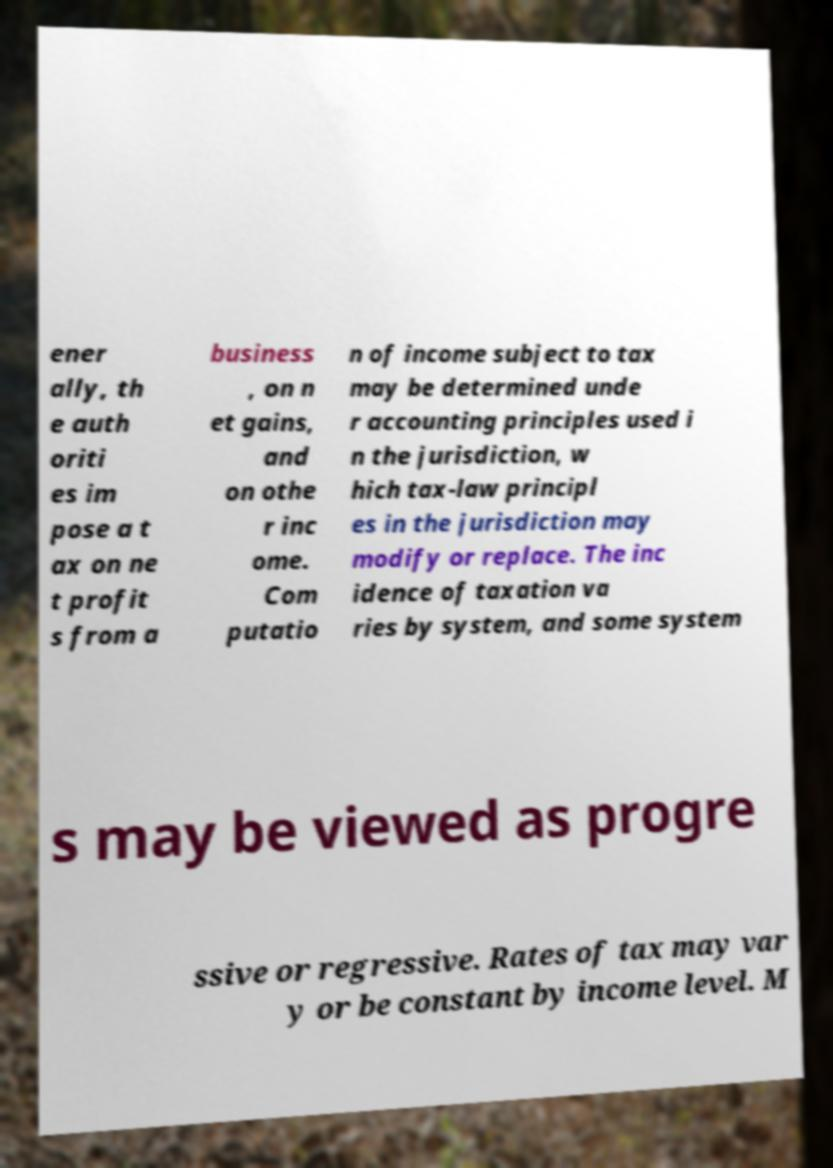What messages or text are displayed in this image? I need them in a readable, typed format. ener ally, th e auth oriti es im pose a t ax on ne t profit s from a business , on n et gains, and on othe r inc ome. Com putatio n of income subject to tax may be determined unde r accounting principles used i n the jurisdiction, w hich tax-law principl es in the jurisdiction may modify or replace. The inc idence of taxation va ries by system, and some system s may be viewed as progre ssive or regressive. Rates of tax may var y or be constant by income level. M 